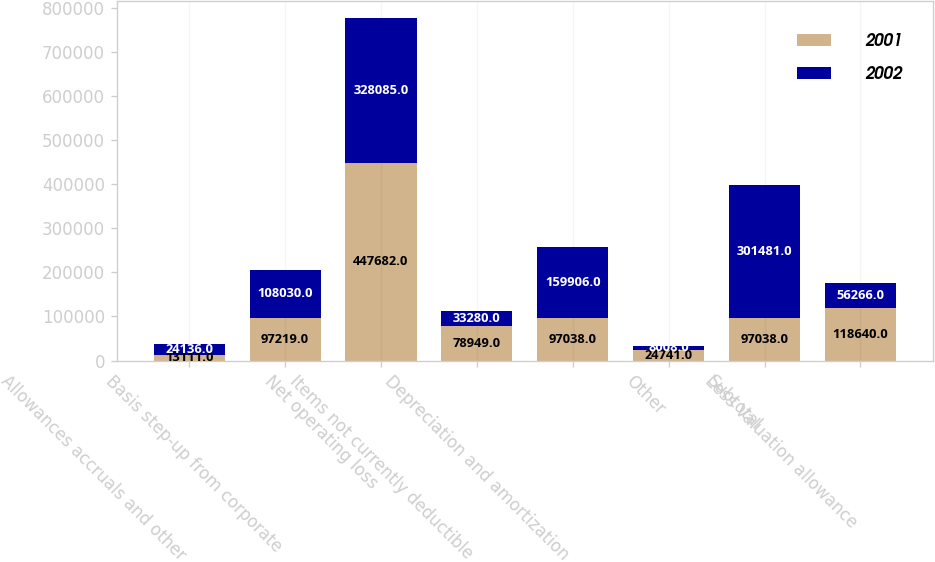Convert chart to OTSL. <chart><loc_0><loc_0><loc_500><loc_500><stacked_bar_chart><ecel><fcel>Allowances accruals and other<fcel>Basis step-up from corporate<fcel>Net operating loss<fcel>Items not currently deductible<fcel>Depreciation and amortization<fcel>Other<fcel>Subtotal<fcel>Less Valuation allowance<nl><fcel>2001<fcel>13111<fcel>97219<fcel>447682<fcel>78949<fcel>97038<fcel>24741<fcel>97038<fcel>118640<nl><fcel>2002<fcel>24136<fcel>108030<fcel>328085<fcel>33280<fcel>159906<fcel>8008<fcel>301481<fcel>56266<nl></chart> 